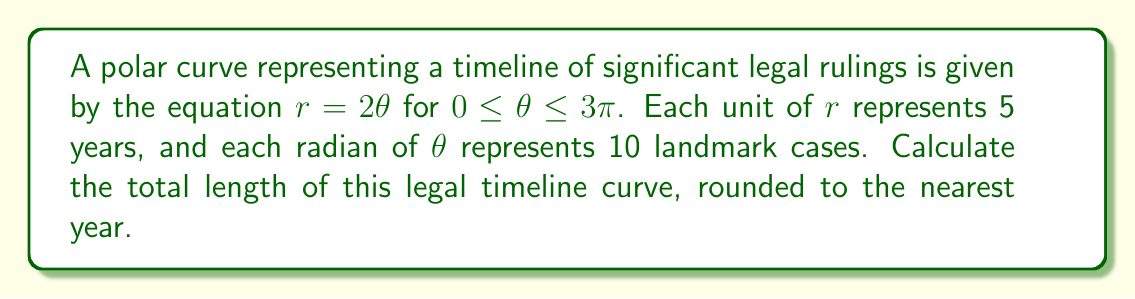Solve this math problem. To find the length of a polar curve, we use the formula:

$$L = \int_a^b \sqrt{r^2 + \left(\frac{dr}{d\theta}\right)^2} d\theta$$

For our curve $r = 2\theta$:

1) First, we need to find $\frac{dr}{d\theta}$:
   $\frac{dr}{d\theta} = 2$

2) Now, let's substitute these into our formula:
   $$L = \int_0^{3\pi} \sqrt{(2\theta)^2 + 2^2} d\theta$$

3) Simplify under the square root:
   $$L = \int_0^{3\pi} \sqrt{4\theta^2 + 4} d\theta$$

4) Factor out the 4:
   $$L = \int_0^{3\pi} 2\sqrt{\theta^2 + 1} d\theta$$

5) This integral can be solved using the substitution $\theta = \sinh u$. After substitution and simplification, we get:
   $$L = 2[\theta\sqrt{\theta^2 + 1} + \ln(\theta + \sqrt{\theta^2 + 1})]_0^{3\pi}$$

6) Evaluate at the limits:
   $$L = 2[(3\pi\sqrt{9\pi^2 + 1} + \ln(3\pi + \sqrt{9\pi^2 + 1})) - (0\sqrt{0^2 + 1} + \ln(0 + \sqrt{0^2 + 1}))]$$

7) Simplify:
   $$L = 2[3\pi\sqrt{9\pi^2 + 1} + \ln(3\pi + \sqrt{9\pi^2 + 1})]$$

8) Calculate this value (you may use a calculator):
   $$L \approx 59.2649$$

9) Remember that each unit of $r$ represents 5 years. So multiply by 5:
   $$59.2649 * 5 \approx 296.3245 \text{ years}$$

10) Rounding to the nearest year:
    $296$ years
Answer: 296 years 